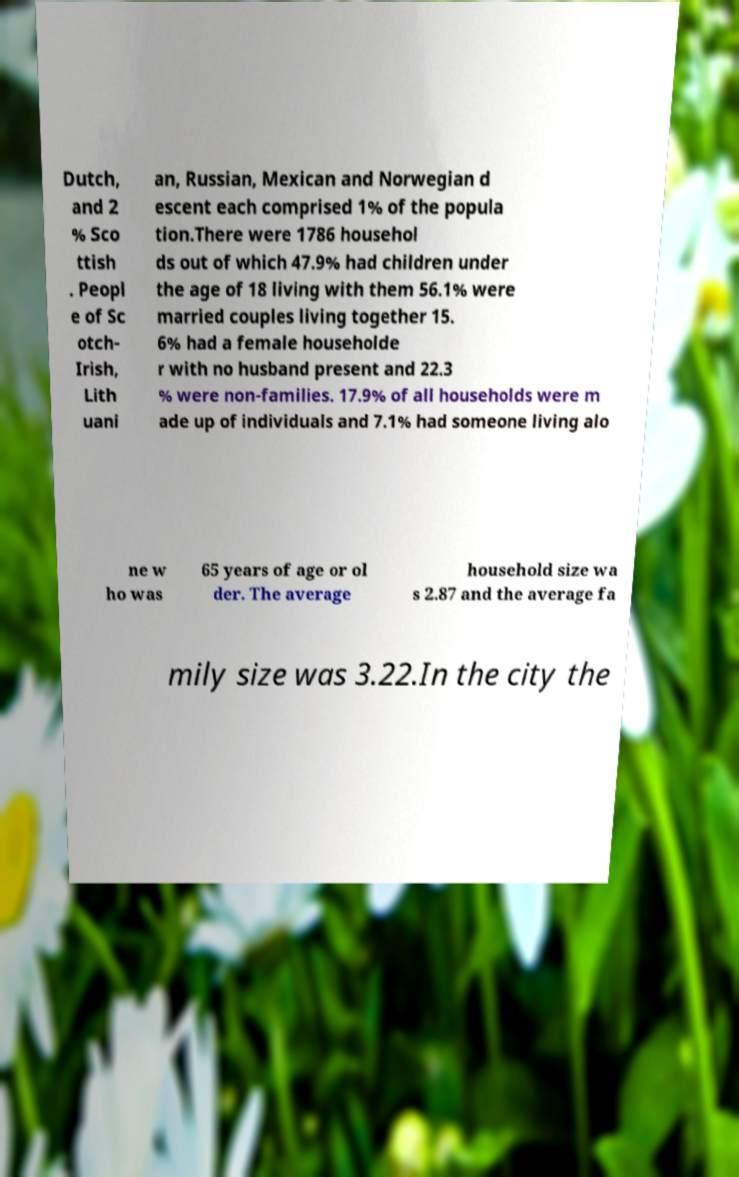Could you extract and type out the text from this image? Dutch, and 2 % Sco ttish . Peopl e of Sc otch- Irish, Lith uani an, Russian, Mexican and Norwegian d escent each comprised 1% of the popula tion.There were 1786 househol ds out of which 47.9% had children under the age of 18 living with them 56.1% were married couples living together 15. 6% had a female householde r with no husband present and 22.3 % were non-families. 17.9% of all households were m ade up of individuals and 7.1% had someone living alo ne w ho was 65 years of age or ol der. The average household size wa s 2.87 and the average fa mily size was 3.22.In the city the 